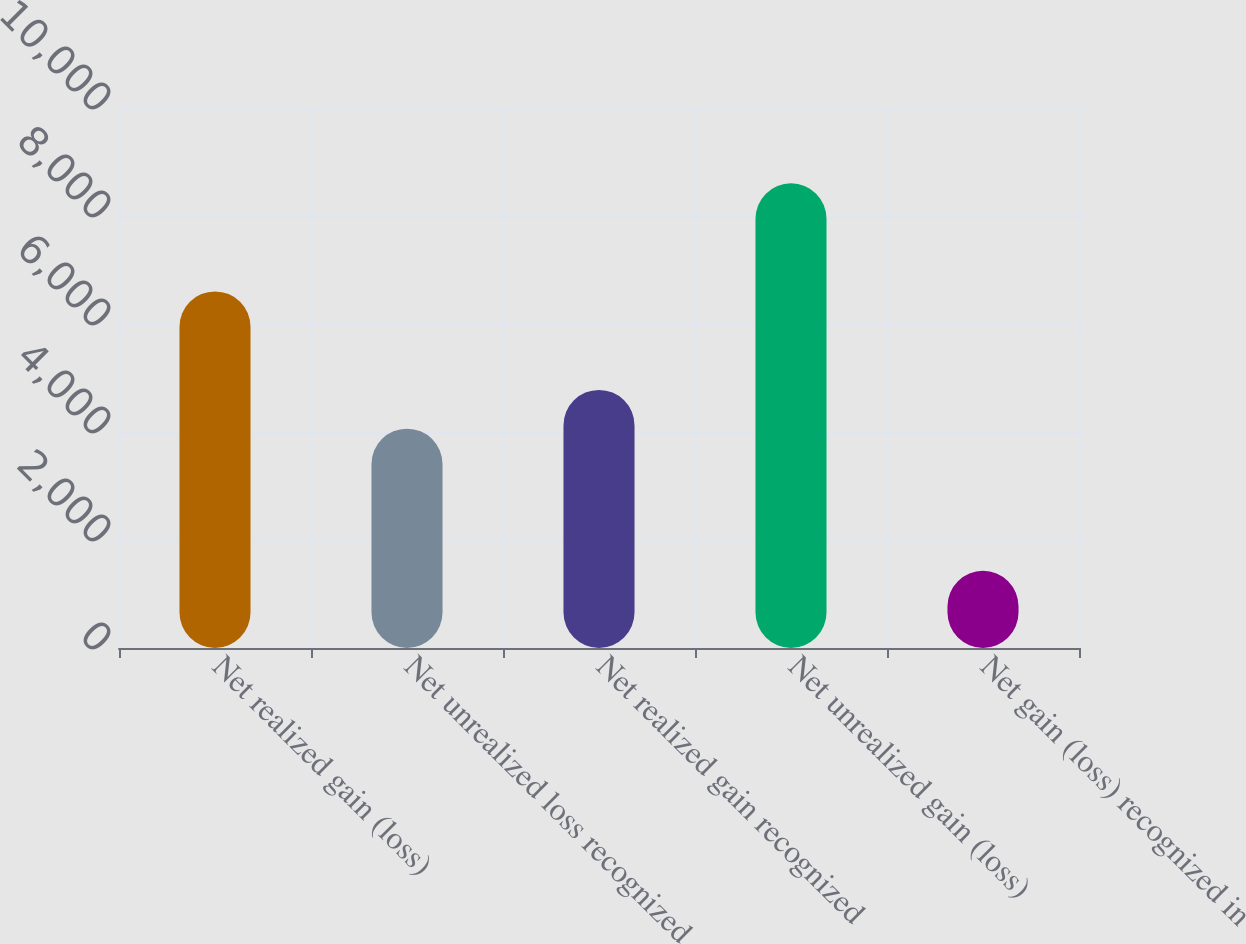Convert chart to OTSL. <chart><loc_0><loc_0><loc_500><loc_500><bar_chart><fcel>Net realized gain (loss)<fcel>Net unrealized loss recognized<fcel>Net realized gain recognized<fcel>Net unrealized gain (loss)<fcel>Net gain (loss) recognized in<nl><fcel>6604<fcel>4062<fcel>4779.5<fcel>8606<fcel>1431<nl></chart> 